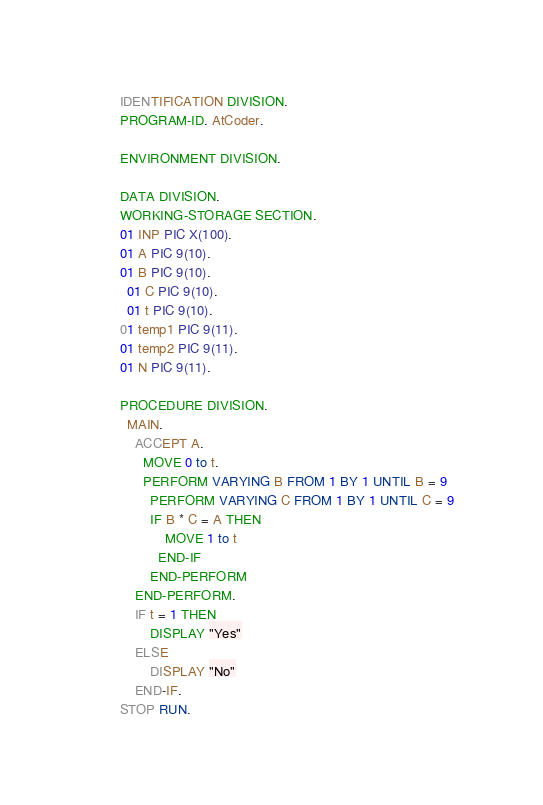<code> <loc_0><loc_0><loc_500><loc_500><_COBOL_>		IDENTIFICATION DIVISION.
        PROGRAM-ID. AtCoder.
      
        ENVIRONMENT DIVISION.
      
        DATA DIVISION.
        WORKING-STORAGE SECTION.
        01 INP PIC X(100).
        01 A PIC 9(10).
        01 B PIC 9(10).
      	01 C PIC 9(10).
      	01 t PIC 9(10).
	    01 temp1 PIC 9(11).
        01 temp2 PIC 9(11).
        01 N PIC 9(11).
      
        PROCEDURE DIVISION.
      	MAIN.
			ACCEPT A.
      		MOVE 0 to t.
      		PERFORM VARYING B FROM 1 BY 1 UNTIL B = 9
      			PERFORM VARYING C FROM 1 BY 1 UNTIL C = 9
      			IF B * C = A THEN
      				MOVE 1 to t
      			END-IF
      			END-PERFORM
      		END-PERFORM.
			IF t = 1 THEN
				DISPLAY "Yes"
			ELSE 
				DISPLAY "No"
			END-IF.
		STOP RUN.</code> 